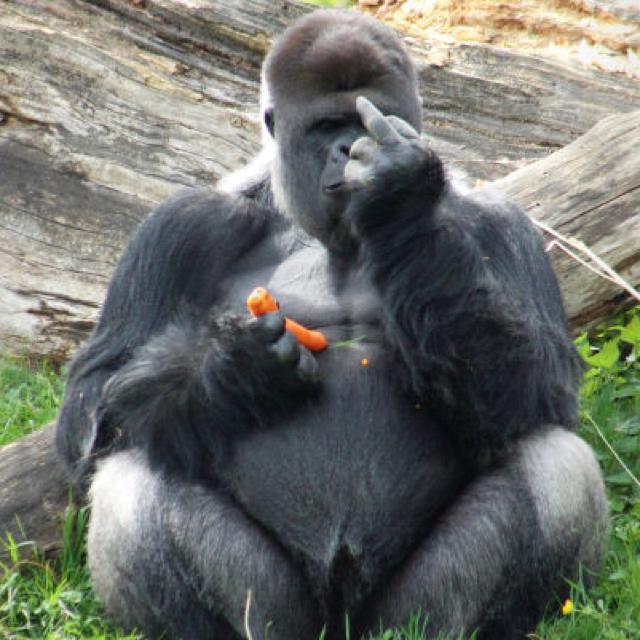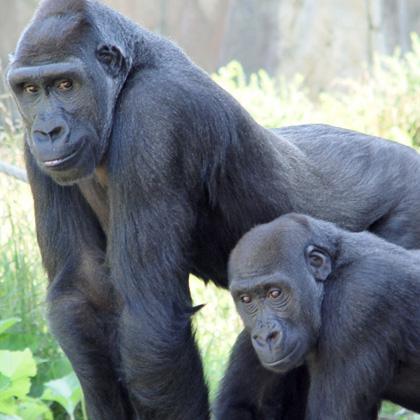The first image is the image on the left, the second image is the image on the right. Examine the images to the left and right. Is the description "The left image shows a large forward-facing ape with its elbows bent and the hand on the right side flipping up its middle finger." accurate? Answer yes or no. Yes. The first image is the image on the left, the second image is the image on the right. Examine the images to the left and right. Is the description "An animal is looking at the camera and flashing its middle finger in the left image." accurate? Answer yes or no. Yes. 